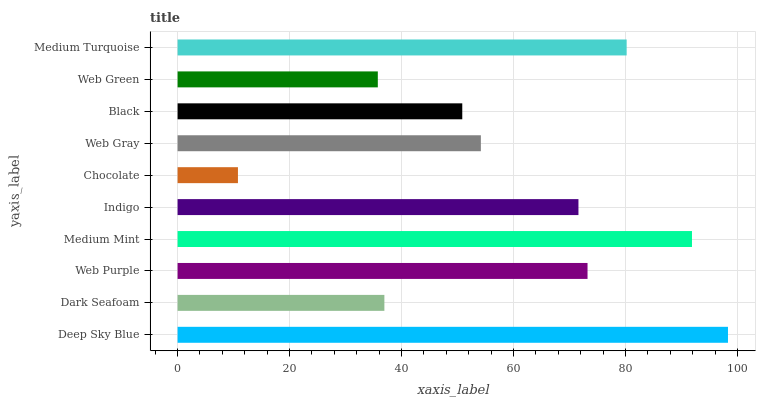Is Chocolate the minimum?
Answer yes or no. Yes. Is Deep Sky Blue the maximum?
Answer yes or no. Yes. Is Dark Seafoam the minimum?
Answer yes or no. No. Is Dark Seafoam the maximum?
Answer yes or no. No. Is Deep Sky Blue greater than Dark Seafoam?
Answer yes or no. Yes. Is Dark Seafoam less than Deep Sky Blue?
Answer yes or no. Yes. Is Dark Seafoam greater than Deep Sky Blue?
Answer yes or no. No. Is Deep Sky Blue less than Dark Seafoam?
Answer yes or no. No. Is Indigo the high median?
Answer yes or no. Yes. Is Web Gray the low median?
Answer yes or no. Yes. Is Web Purple the high median?
Answer yes or no. No. Is Medium Mint the low median?
Answer yes or no. No. 